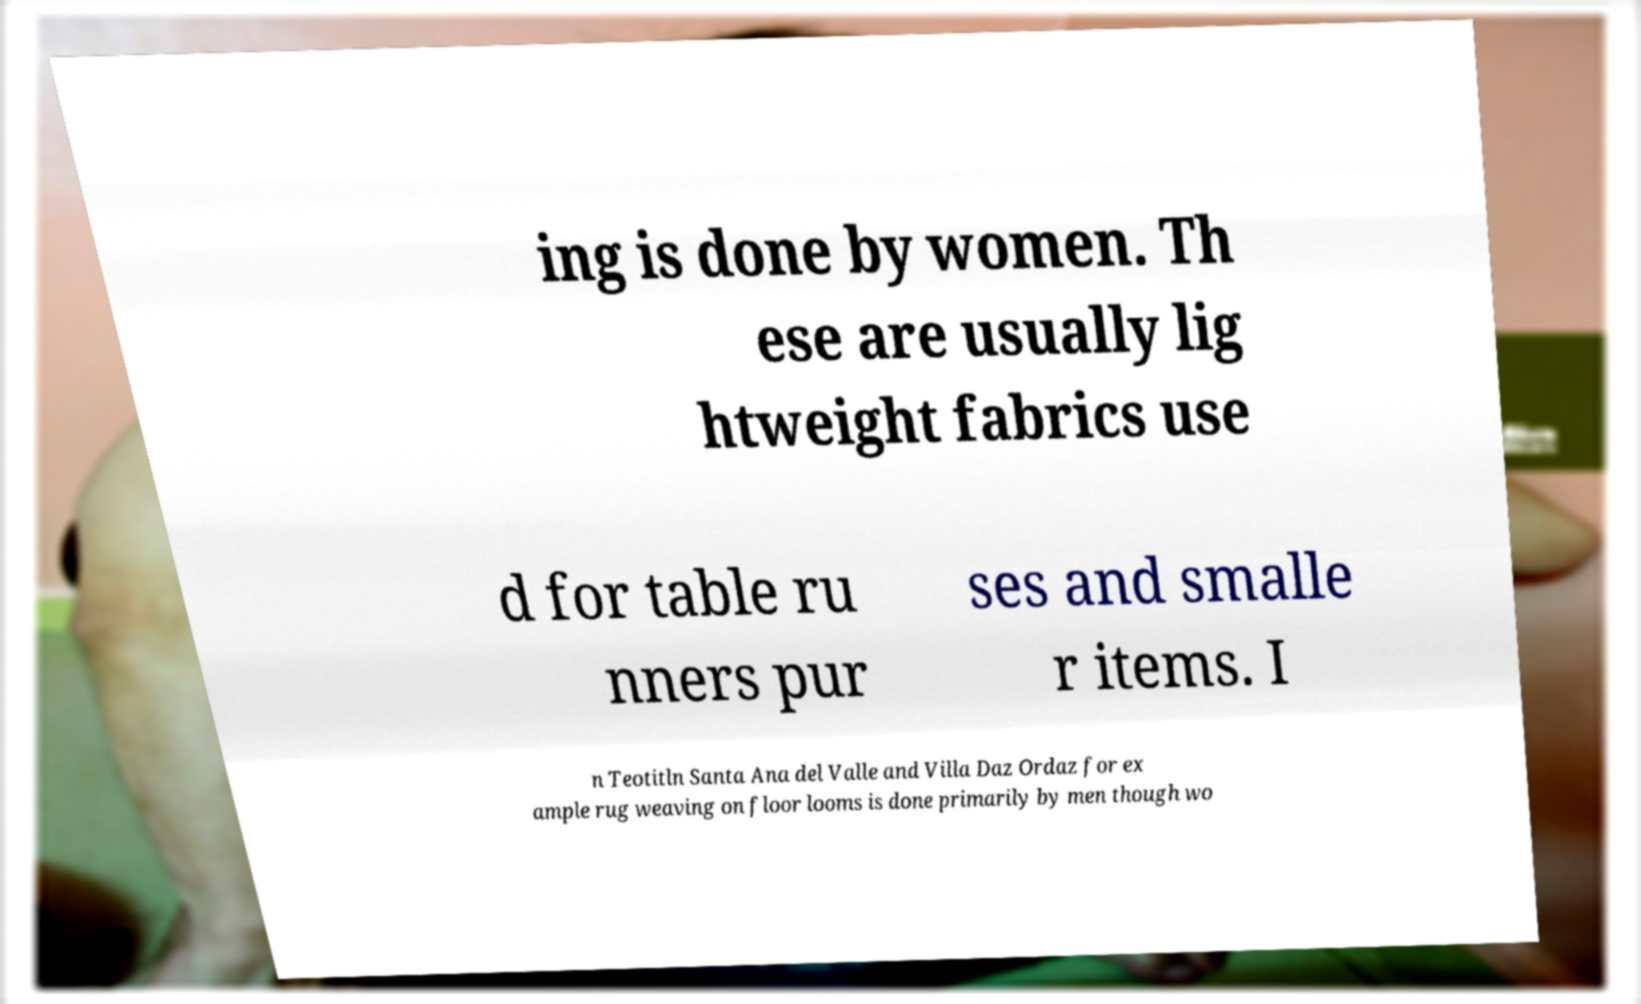What messages or text are displayed in this image? I need them in a readable, typed format. ing is done by women. Th ese are usually lig htweight fabrics use d for table ru nners pur ses and smalle r items. I n Teotitln Santa Ana del Valle and Villa Daz Ordaz for ex ample rug weaving on floor looms is done primarily by men though wo 